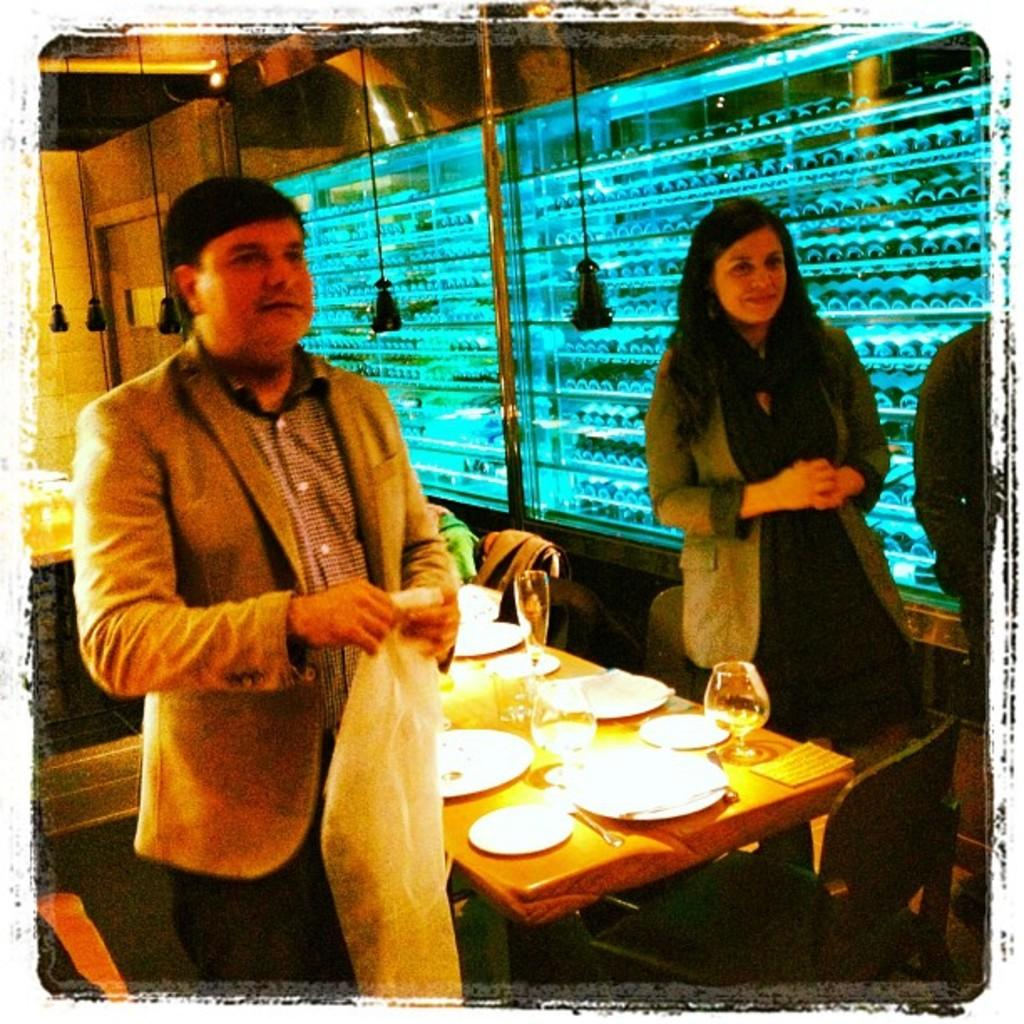How many people are in the image? There is a man and a woman in the image. What are the man and woman doing in the image? The man and woman are on either side of a table. What items can be seen on the table in the image? Plates, glasses, and tissues are placed on the table. What can be seen in the background of the image? There is a window and a wall in the background of the image. What type of grass can be seen growing in the bedroom in the image? There is no bedroom or grass present in the image; it features a man and a woman on either side of a table with plates, glasses, and tissues, and a background with a window and wall. 